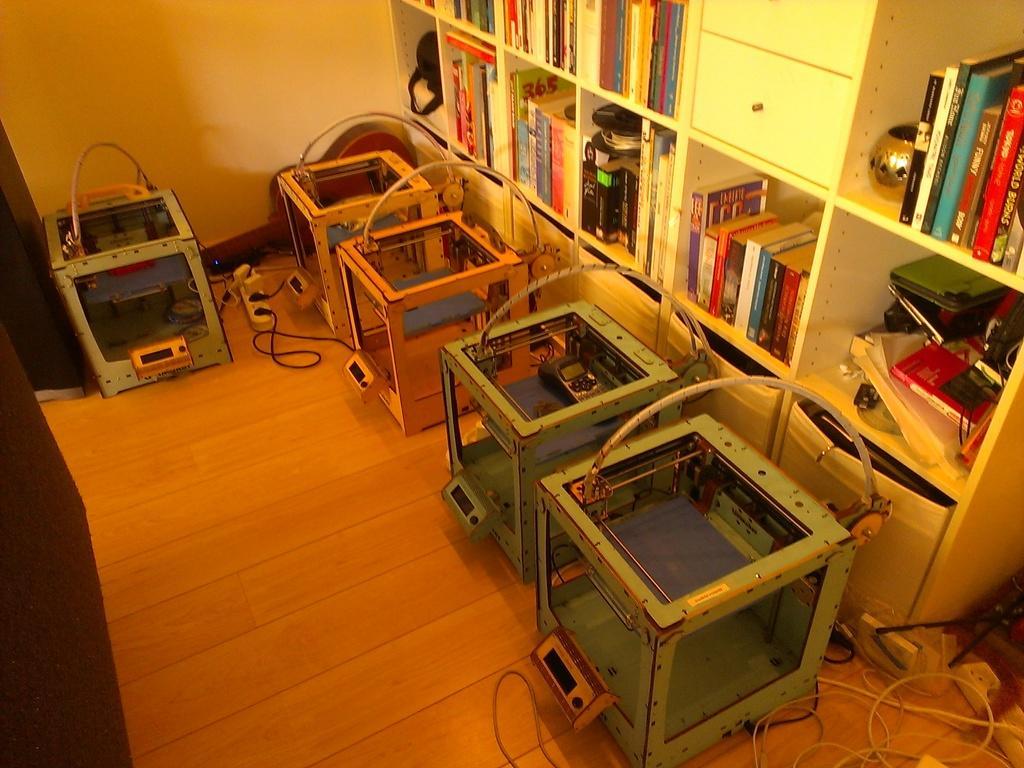In one or two sentences, can you explain what this image depicts? In this image we can see many machinery objects, many cables and extension boxes on the ground. There are many books and objects placed on the shelves. 